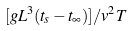<formula> <loc_0><loc_0><loc_500><loc_500>[ g L ^ { 3 } ( t _ { s } - t _ { \infty } ) ] / v ^ { 2 } T</formula> 